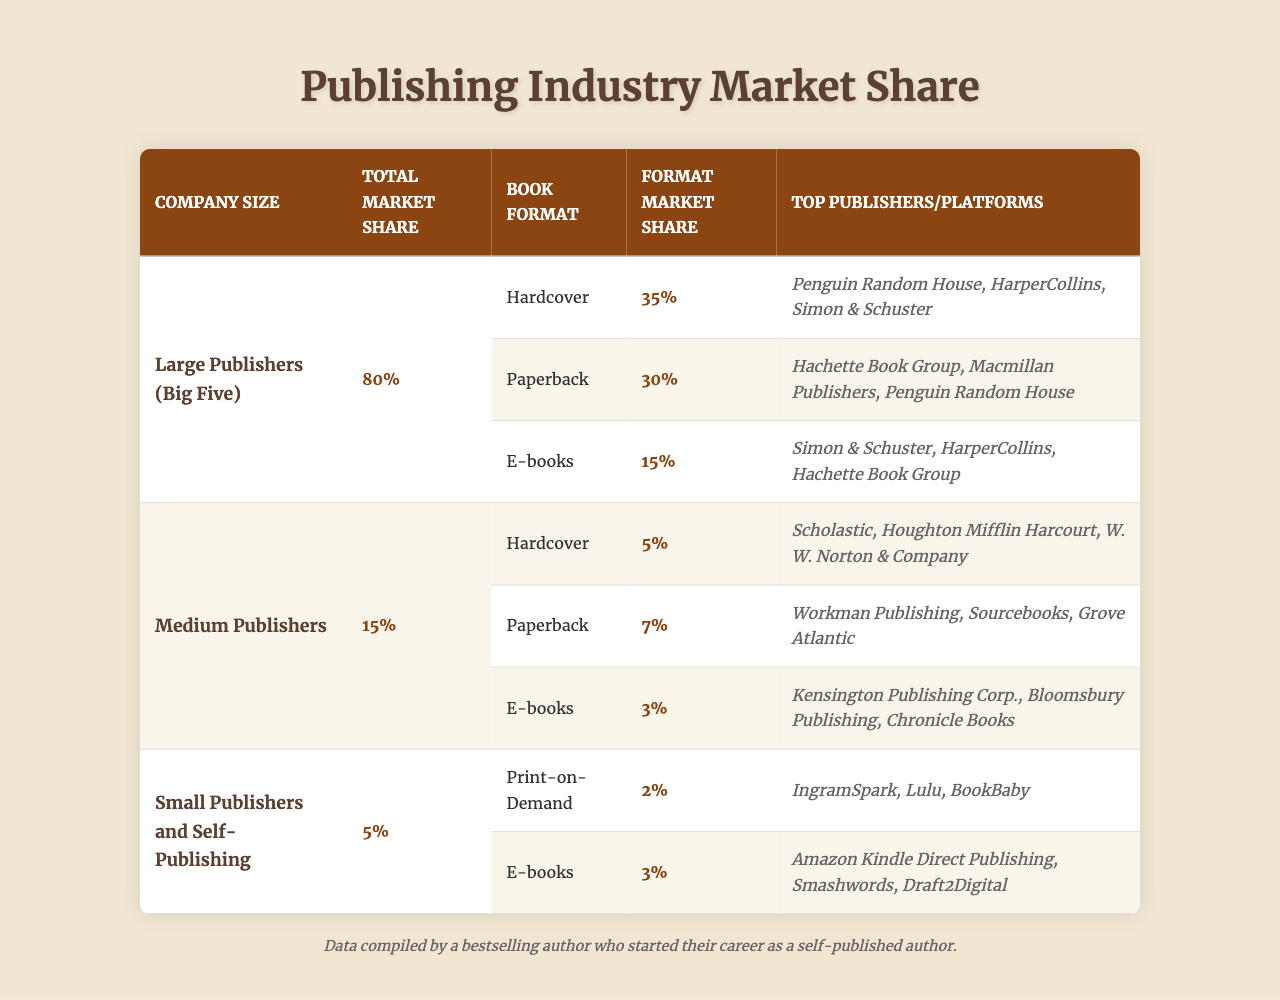What is the total market share of large publishers? The table shows that large publishers have a total market share of 80%.
Answer: 80% Which book format has the highest market share among large publishers? According to the table, the hardcover format has the highest market share at 35%.
Answer: Hardcover What percentage of the market share do medium publishers hold? The table indicates that medium publishers hold a total market share of 15%.
Answer: 15% What are the top three publishers for hardcover books in large publishing? The table lists Penguin Random House, HarperCollins, and Simon & Schuster as the top publishers for hardcover books.
Answer: Penguin Random House, HarperCollins, Simon & Schuster Which company size has the lowest market share? The table reveals that small publishers and self-publishing have the lowest market share at 5%.
Answer: Small Publishers and Self-Publishing What is the market share of e-books for small publishers? The table states that e-books have a market share of 3% for small publishers and self-publishing.
Answer: 3% How much market share do paperback books account for in total? The total market share for paperback books can be calculated by adding the shares from large and medium publishers, which are 30% and 7%, respectively. Thus, the total is 30% + 7% = 37%.
Answer: 37% Are the top publishers for e-books in the small publishing category different from those in large publishing? Yes, the top publishers for e-books in small publishing (Amazon Kindle Direct Publishing, Smashwords, Draft2Digital) are different from those in large publishing (Simon & Schuster, HarperCollins, Hachette Book Group).
Answer: Yes What format holds the least market share in medium publishers? According to the table, the hardcover format with a market share of 5% holds the least market share among medium publishers since the other formats have higher shares (7% for paperback and 3% for e-books).
Answer: Hardcover What is the combined market share of paperback and e-books for large publishers? To find the combined market share, sum the market shares for paperback (30%) and e-books (15%) for large publishers: 30% + 15% = 45%.
Answer: 45% How do the market share percentages of small publishers compare to large publishers across all formats combined? Small publishers have a total market share of 5%, while large publishers have a total market share of 80%. This indicates that small publishers hold significantly less market share compared to large publishers.
Answer: Small publishers have much less market share 